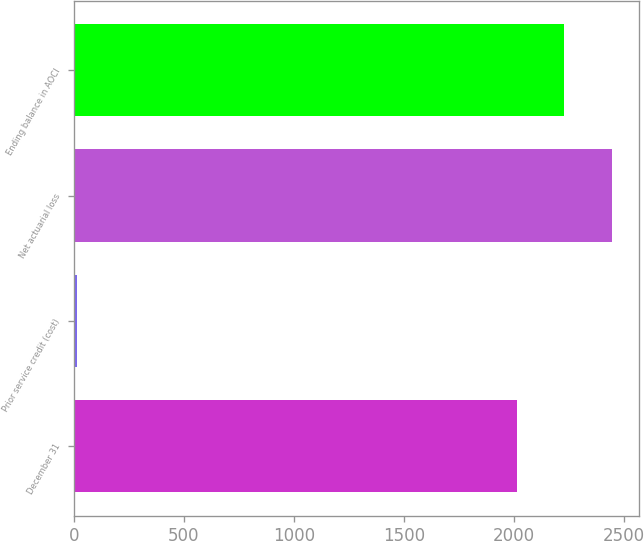Convert chart to OTSL. <chart><loc_0><loc_0><loc_500><loc_500><bar_chart><fcel>December 31<fcel>Prior service credit (cost)<fcel>Net actuarial loss<fcel>Ending balance in AOCI<nl><fcel>2011<fcel>14<fcel>2444.8<fcel>2227.9<nl></chart> 